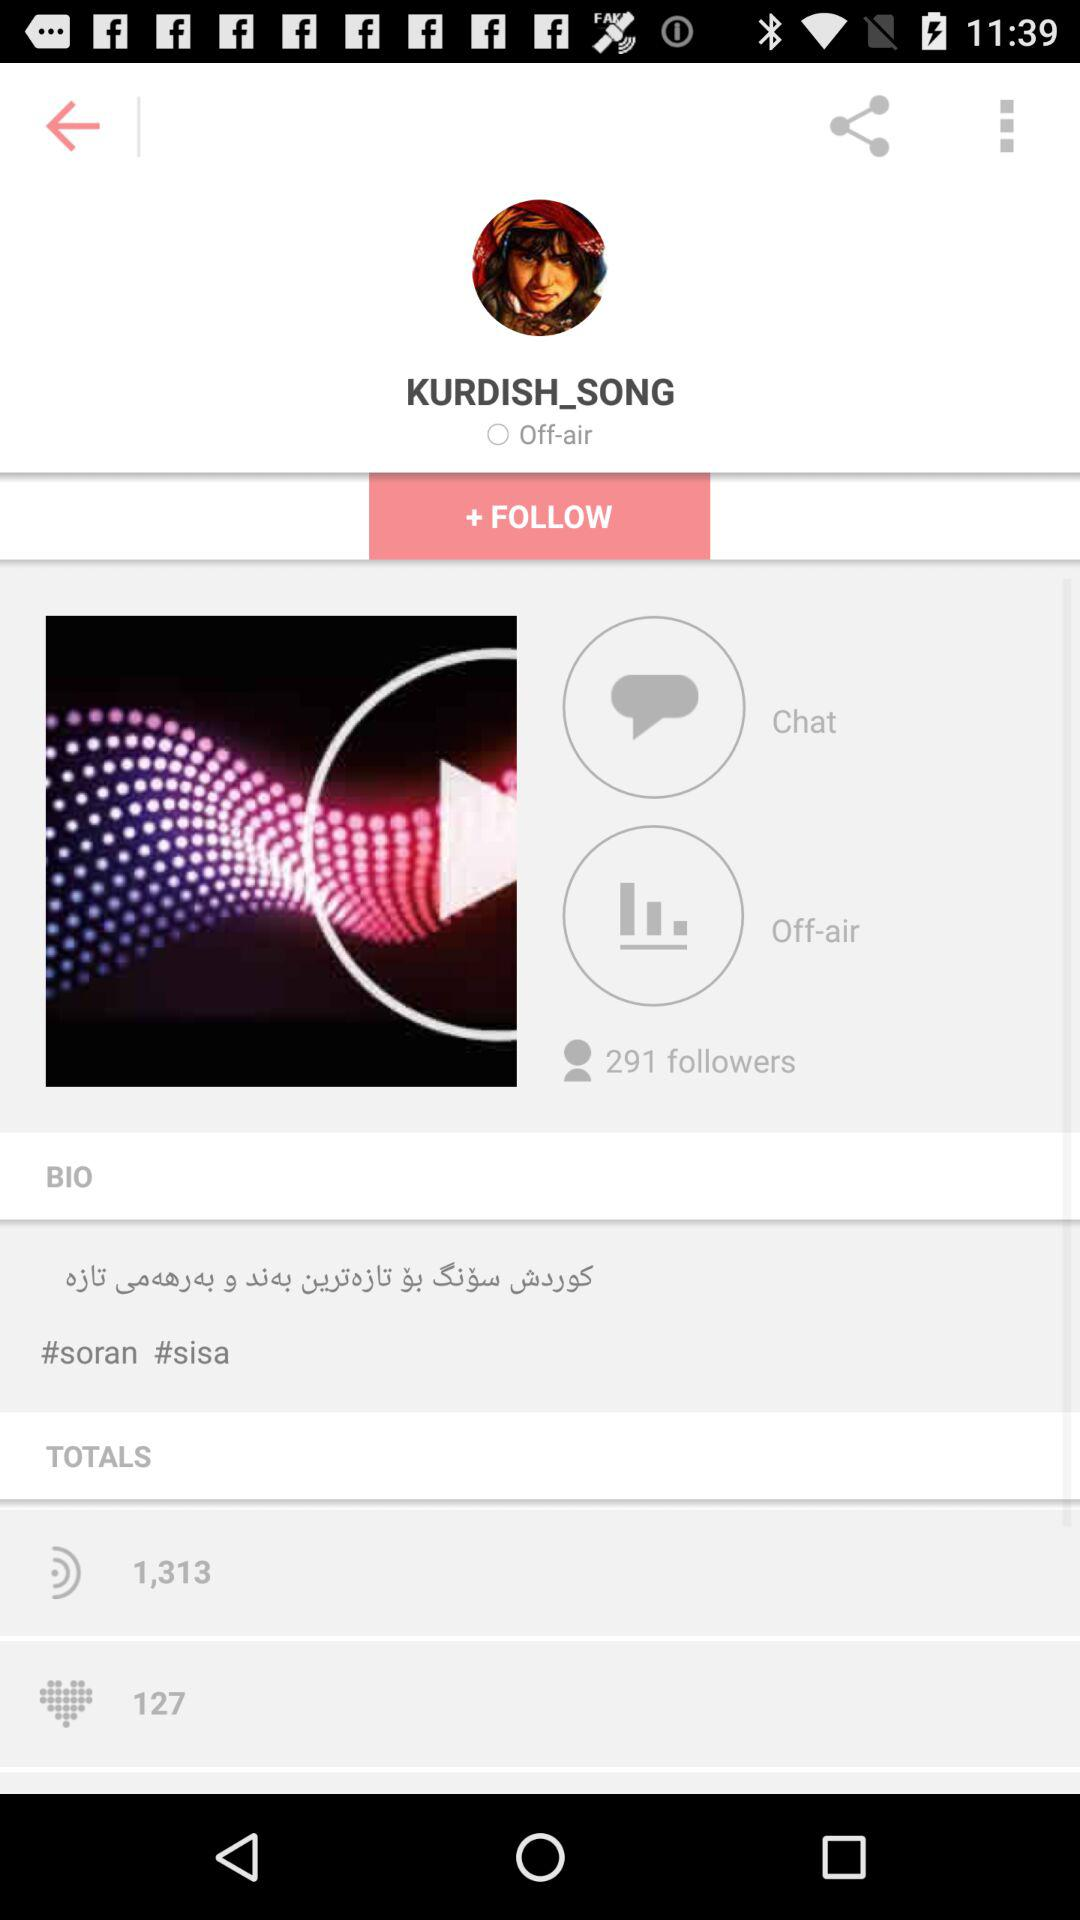How many followers are there? There are 291 followers. 